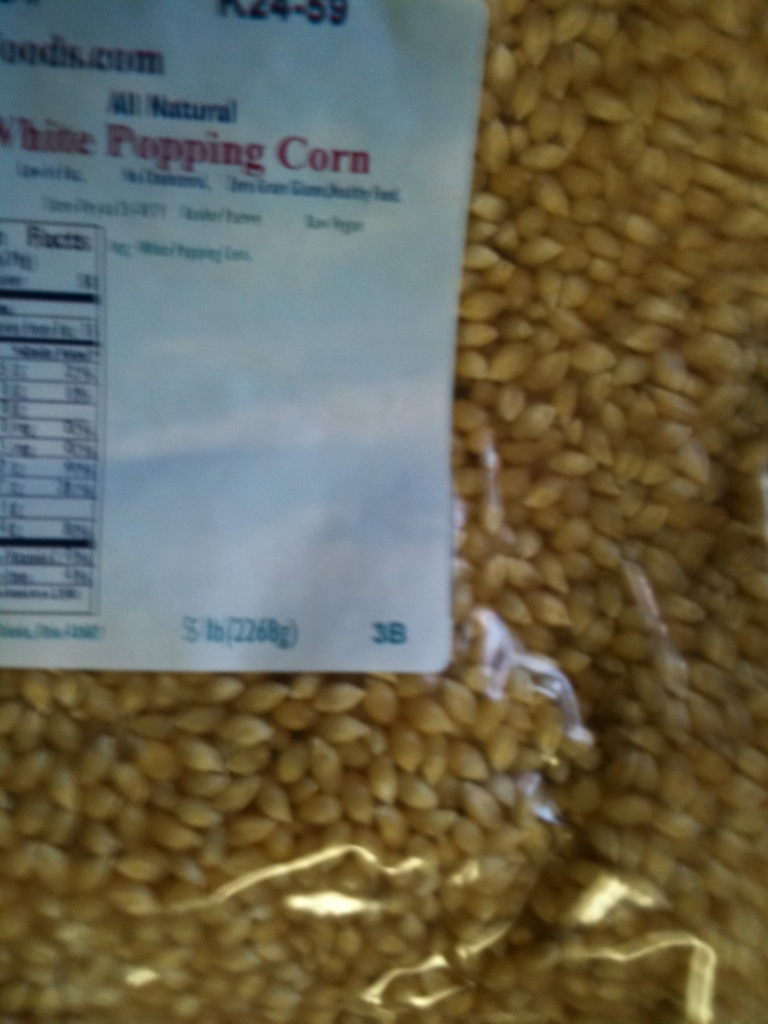Could you suggest a fun recipe using this popping corn? Absolutely! One fun recipe is caramel popcorn. Start by popping the corn using your preferred method. In a saucepan, melt butter and stir in brown sugar, corn syrup, and a pinch of salt. Bring this mixture to a boil, then add baking soda and vanilla extract. Pour the caramel sauce over the popped corn, stir to coat evenly, and bake at a low temperature, stirring occasionally, until the popcorn is crisp and coated. Enjoy your sweet and crunchy treat! 